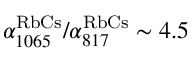Convert formula to latex. <formula><loc_0><loc_0><loc_500><loc_500>\alpha _ { 1 0 6 5 } ^ { R b C s } / \alpha _ { 8 1 7 } ^ { R b C s } \sim 4 . 5</formula> 